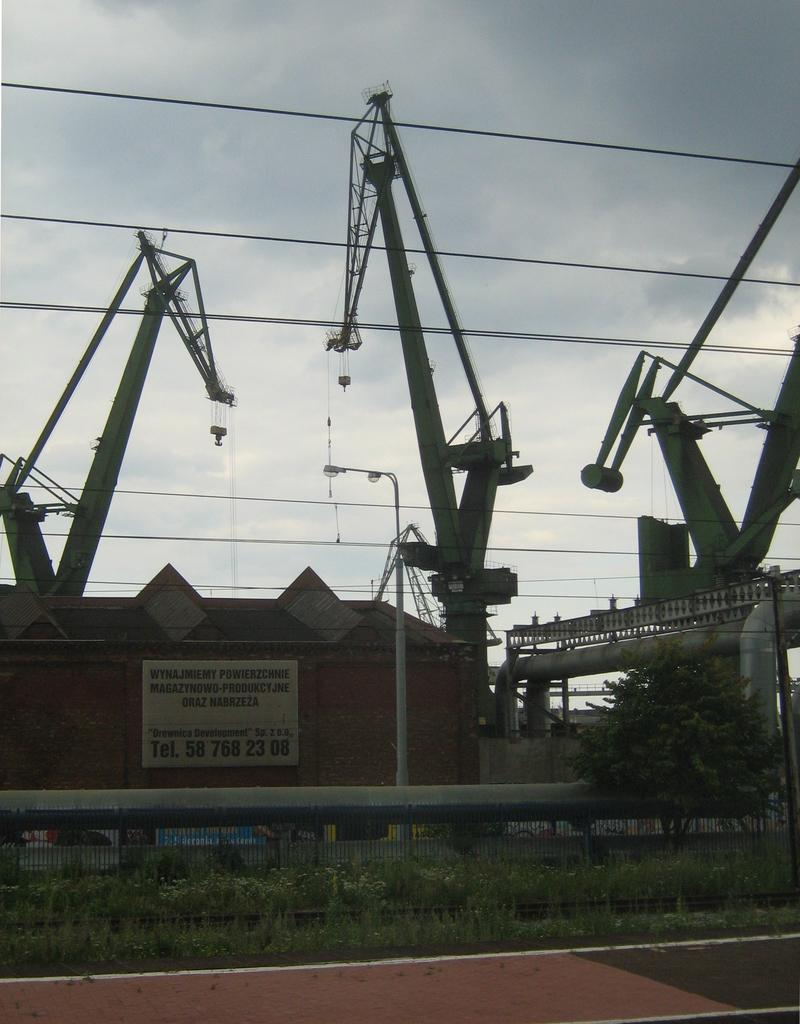What structure is located on the left side of the image? There is a house on the left side of the image. What type of vegetation is on the right side of the image? There is a tree on the right side of the image. What type of barrier is visible from left to right in the image? There is fencing visible from left to right in the image. What type of construction equipment can be seen in the image? There are cranes in the image. What type of infrastructure is visible in the image? There are wires visible in the image. What is the condition of the sky in the image? The sky is cloudy in the image. Can you see a bucket hanging from the tree in the image? There is no bucket hanging from the tree in the image. Are there any fangs visible on the cranes in the image? There are no fangs visible on the cranes in the image. 